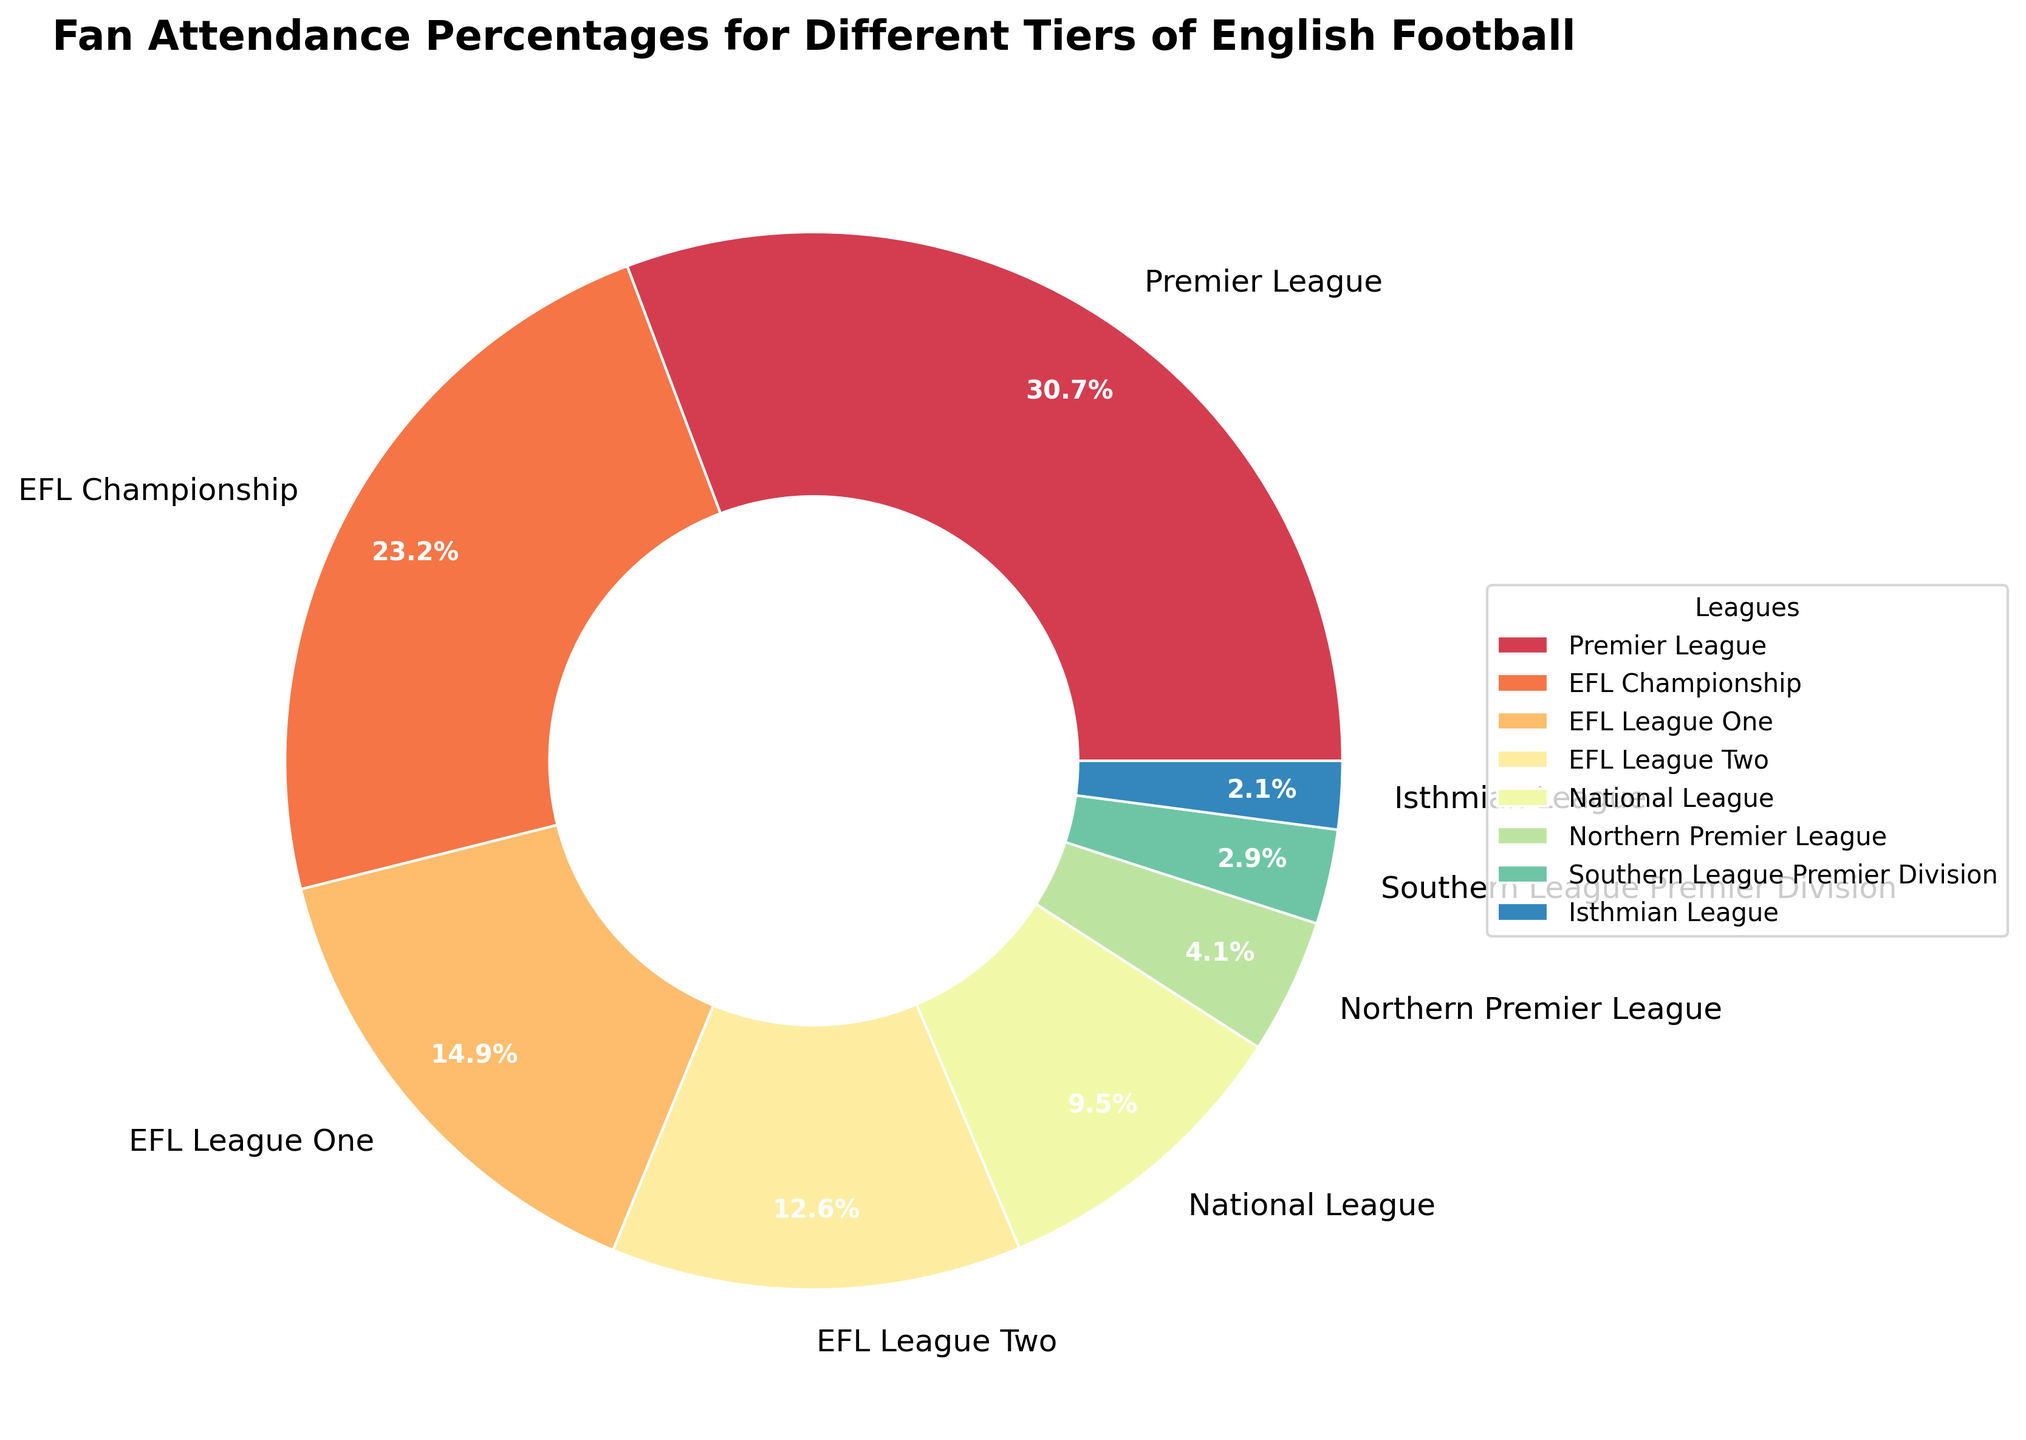What tier has the highest fan attendance percentage? The Premier League has the highest fan attendance percentage, which can be identified by the largest wedge on the pie chart. The corresponding value is 94.5%.
Answer: Premier League Which league has the lowest attendance percentage? By looking at the smallest wedge on the pie chart, the Isthmian League has the lowest attendance percentage at 6.4%.
Answer: Isthmian League What is the approximate combined attendance percentage for EFL League One and EFL League Two? Add the percentages for EFL League One (45.8%) and EFL League Two (38.6%). The combined attendance percentage is 45.8 + 38.6 = 84.4%.
Answer: 84.4% How much higher is the Premier League's attendance percentage compared to the National League? Subtract the National League's percentage (29.3%) from the Premier League's percentage (94.5%). The difference is 94.5 - 29.3 = 65.2%.
Answer: 65.2% Which leagues have an attendance percentage greater than 50%? Identify wedges that represent leagues with percentages over 50%. The Premier League (94.5%) and the EFL Championship (71.2%) meet this criterion.
Answer: Premier League, EFL Championship How do the attendance percentages for the Northern Premier League and the Southern League Premier Division compare? The Northern Premier League has an attendance percentage of 12.7% and the Southern League Premier Division has 8.9%. Therefore, the Northern Premier League has a higher percentage.
Answer: Northern Premier League > Southern League Premier Division What is the approximate average attendance percentage for EFL Championship, EFL League One, and EFL League Two combined? Sum the percentages for EFL Championship (71.2%), EFL League One (45.8%), and EFL League Two (38.6%) and divide by 3. (71.2 + 45.8 + 38.6) / 3 = 51.87%.
Answer: 51.87% Which league stands out visually with the brightest color on the pie chart? Since the Premier League typically attracts the highest interest, it is often highlighted with a prominent or bright color for easy identification on the pie chart.
Answer: Premier League If you combine the attendance percentages of the National League and all leagues below it in the tier list, what is the total percentage? Add the percentages for the National League (29.3%), Northern Premier League (12.7%), Southern League Premier Division (8.9%), and Isthmian League (6.4%). The total is 29.3 + 12.7 + 8.9 + 6.4 = 57.3%.
Answer: 57.3% Out of the leagues with an attendance percentage below 40%, which one has the highest percentage? Among the leagues with percentages below 40% (EFL League Two, National League, Northern Premier League, Southern League Premier Division, Isthmian League), the EFL League Two at 38.6% has the highest.
Answer: EFL League Two Which league is closest to having an attendance percentage of 30%? The National League is the closest with an attendance percentage of 29.3%.
Answer: National League 